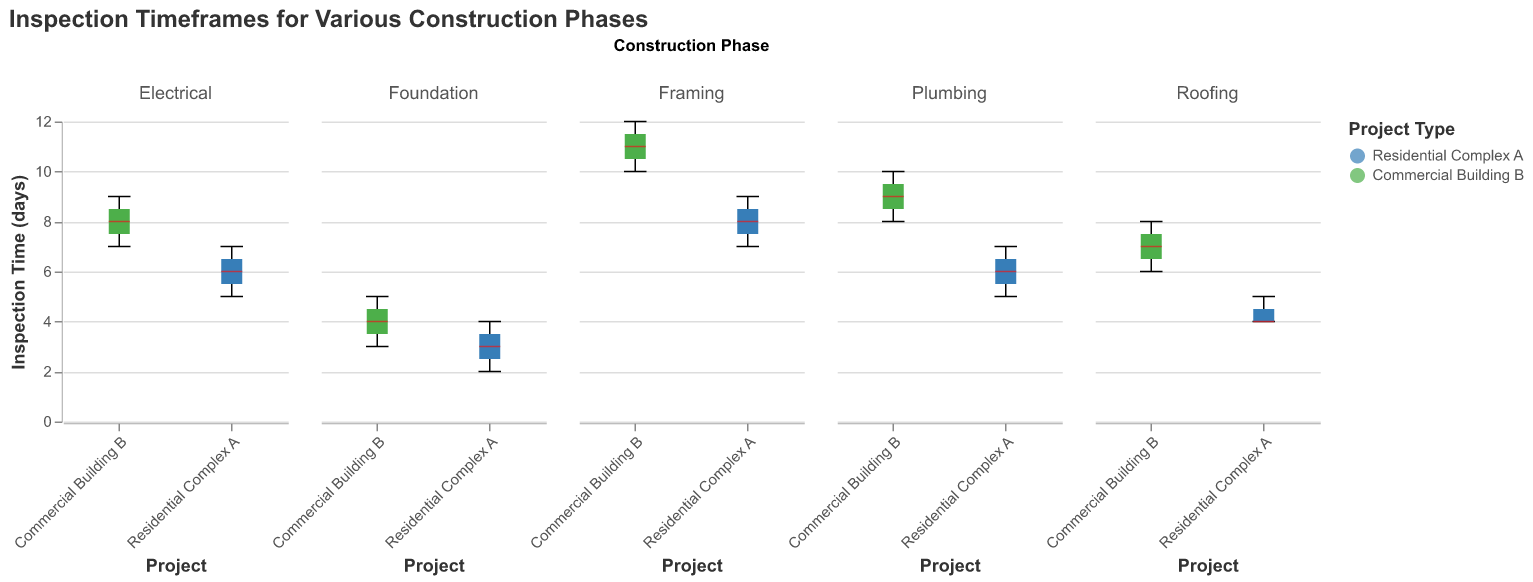What is the title of the figure? The title is displayed at the top of the figure.
Answer: Inspection Timeframes for Various Construction Phases Which project has the highest median inspection time for the Framing phase? By looking at the box plot for the Framing phase, identify which project's median value is higher.
Answer: Commercial Building B What is the range of inspection times for the Plumbing phase in Residential Complex A? In the box plot for Plumbing in Residential Complex A, determine the smallest and largest values within the whiskers to find the range.
Answer: 5 to 7 days Are there any phases where both projects have the same median inspection time? Check the median lines in each box plot across all phases to see if any pairs of boxes have the same median line.
Answer: No Which phase has the highest variation in inspection times for Commercial Building B? Look at the length of the whiskers and interquartile range (IQR) for each phase box plot of Commercial Building B to identify the highest variation.
Answer: Framing What is the median inspection time for the Electrical phase in Residential Complex A? Identify the central line within the box plot for the Electrical phase under Residential Complex A.
Answer: 6 days How does the variation in inspection times for the Roofing phase compare between Residential Complex A and Commercial Building B? Compare the length of the whiskers and the IQR for the Roofing phase for both projects to understand the variation.
Answer: Commercial Building B has greater variation than Residential Complex A What is the difference in the maximum inspection time for the Foundation phase between the two projects? Determine the maximum values at the top of the whiskers for both projects in the Foundation box plot and calculate the difference.
Answer: 1 day Are the inspection times generally higher for the Plumbing phase compared to the Foundation phase within Residential Complex A? Compare the median lines and the spread of the whiskers for the Plumbing and Foundation box plots under Residential Complex A.
Answer: Yes, Plumbing has higher median and range Which phase shows the smallest interquartile range (IQR) for Commercial Building B? Look at the boxes' lengths for each phase of Commercial Building B to find the one with the smallest IQR.
Answer: Electrical 